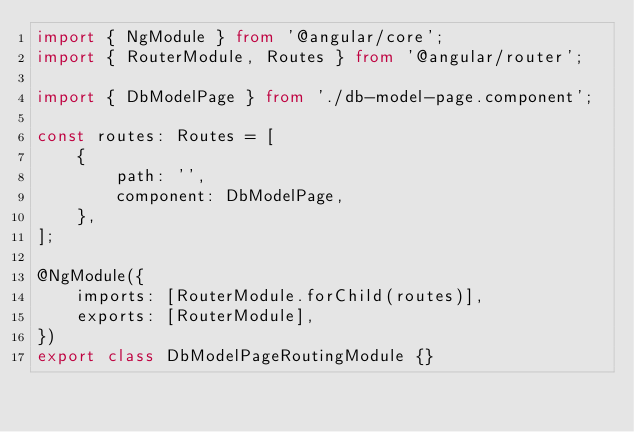Convert code to text. <code><loc_0><loc_0><loc_500><loc_500><_TypeScript_>import { NgModule } from '@angular/core';
import { RouterModule, Routes } from '@angular/router';

import { DbModelPage } from './db-model-page.component';

const routes: Routes = [
	{
		path: '',
		component: DbModelPage,
	},
];

@NgModule({
	imports: [RouterModule.forChild(routes)],
	exports: [RouterModule],
})
export class DbModelPageRoutingModule {}
</code> 